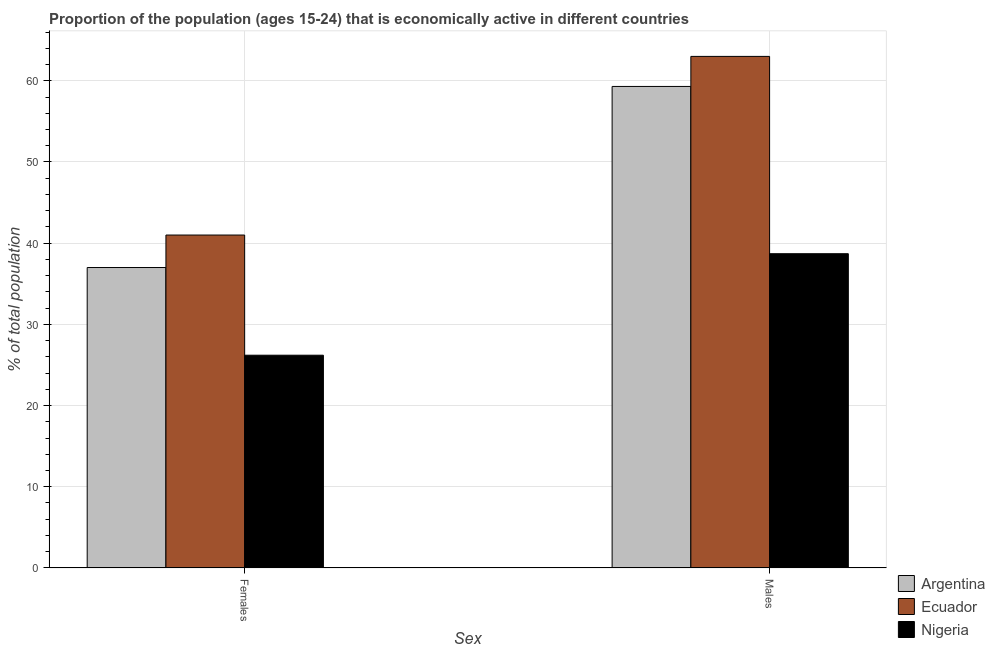How many groups of bars are there?
Your answer should be compact. 2. What is the label of the 1st group of bars from the left?
Provide a succinct answer. Females. What is the percentage of economically active male population in Argentina?
Provide a succinct answer. 59.3. Across all countries, what is the minimum percentage of economically active male population?
Provide a short and direct response. 38.7. In which country was the percentage of economically active female population maximum?
Provide a succinct answer. Ecuador. In which country was the percentage of economically active male population minimum?
Give a very brief answer. Nigeria. What is the total percentage of economically active female population in the graph?
Make the answer very short. 104.2. What is the difference between the percentage of economically active female population in Nigeria and that in Ecuador?
Offer a terse response. -14.8. What is the difference between the percentage of economically active female population in Ecuador and the percentage of economically active male population in Nigeria?
Provide a succinct answer. 2.3. What is the average percentage of economically active male population per country?
Provide a succinct answer. 53.67. What is the difference between the percentage of economically active female population and percentage of economically active male population in Ecuador?
Your response must be concise. -22. In how many countries, is the percentage of economically active female population greater than 48 %?
Provide a short and direct response. 0. What is the ratio of the percentage of economically active female population in Argentina to that in Nigeria?
Provide a succinct answer. 1.41. Is the percentage of economically active male population in Argentina less than that in Nigeria?
Keep it short and to the point. No. What does the 3rd bar from the left in Females represents?
Your response must be concise. Nigeria. What does the 1st bar from the right in Females represents?
Provide a short and direct response. Nigeria. How many bars are there?
Keep it short and to the point. 6. How many countries are there in the graph?
Keep it short and to the point. 3. Are the values on the major ticks of Y-axis written in scientific E-notation?
Offer a very short reply. No. Does the graph contain grids?
Your response must be concise. Yes. How many legend labels are there?
Ensure brevity in your answer.  3. How are the legend labels stacked?
Your answer should be very brief. Vertical. What is the title of the graph?
Your answer should be very brief. Proportion of the population (ages 15-24) that is economically active in different countries. Does "Haiti" appear as one of the legend labels in the graph?
Keep it short and to the point. No. What is the label or title of the X-axis?
Provide a short and direct response. Sex. What is the label or title of the Y-axis?
Provide a succinct answer. % of total population. What is the % of total population of Argentina in Females?
Offer a very short reply. 37. What is the % of total population of Nigeria in Females?
Make the answer very short. 26.2. What is the % of total population in Argentina in Males?
Ensure brevity in your answer.  59.3. What is the % of total population in Nigeria in Males?
Keep it short and to the point. 38.7. Across all Sex, what is the maximum % of total population of Argentina?
Ensure brevity in your answer.  59.3. Across all Sex, what is the maximum % of total population in Ecuador?
Your answer should be very brief. 63. Across all Sex, what is the maximum % of total population of Nigeria?
Your response must be concise. 38.7. Across all Sex, what is the minimum % of total population in Nigeria?
Provide a succinct answer. 26.2. What is the total % of total population of Argentina in the graph?
Offer a very short reply. 96.3. What is the total % of total population of Ecuador in the graph?
Offer a very short reply. 104. What is the total % of total population of Nigeria in the graph?
Your answer should be very brief. 64.9. What is the difference between the % of total population in Argentina in Females and that in Males?
Make the answer very short. -22.3. What is the difference between the % of total population in Ecuador in Females and that in Males?
Provide a short and direct response. -22. What is the difference between the % of total population in Nigeria in Females and that in Males?
Keep it short and to the point. -12.5. What is the difference between the % of total population in Argentina in Females and the % of total population in Ecuador in Males?
Offer a terse response. -26. What is the average % of total population of Argentina per Sex?
Offer a terse response. 48.15. What is the average % of total population in Nigeria per Sex?
Offer a very short reply. 32.45. What is the difference between the % of total population in Argentina and % of total population in Nigeria in Females?
Offer a very short reply. 10.8. What is the difference between the % of total population of Ecuador and % of total population of Nigeria in Females?
Ensure brevity in your answer.  14.8. What is the difference between the % of total population of Argentina and % of total population of Nigeria in Males?
Your response must be concise. 20.6. What is the difference between the % of total population of Ecuador and % of total population of Nigeria in Males?
Offer a terse response. 24.3. What is the ratio of the % of total population of Argentina in Females to that in Males?
Offer a very short reply. 0.62. What is the ratio of the % of total population of Ecuador in Females to that in Males?
Offer a terse response. 0.65. What is the ratio of the % of total population in Nigeria in Females to that in Males?
Offer a very short reply. 0.68. What is the difference between the highest and the second highest % of total population of Argentina?
Provide a short and direct response. 22.3. What is the difference between the highest and the second highest % of total population of Nigeria?
Offer a very short reply. 12.5. What is the difference between the highest and the lowest % of total population in Argentina?
Give a very brief answer. 22.3. What is the difference between the highest and the lowest % of total population of Nigeria?
Keep it short and to the point. 12.5. 